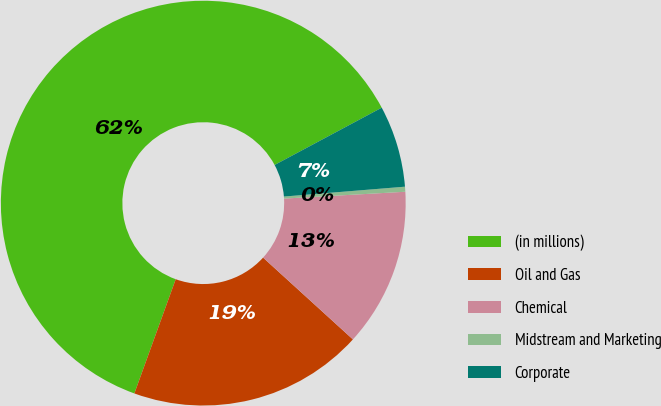<chart> <loc_0><loc_0><loc_500><loc_500><pie_chart><fcel>(in millions)<fcel>Oil and Gas<fcel>Chemical<fcel>Midstream and Marketing<fcel>Corporate<nl><fcel>61.65%<fcel>18.77%<fcel>12.65%<fcel>0.4%<fcel>6.52%<nl></chart> 